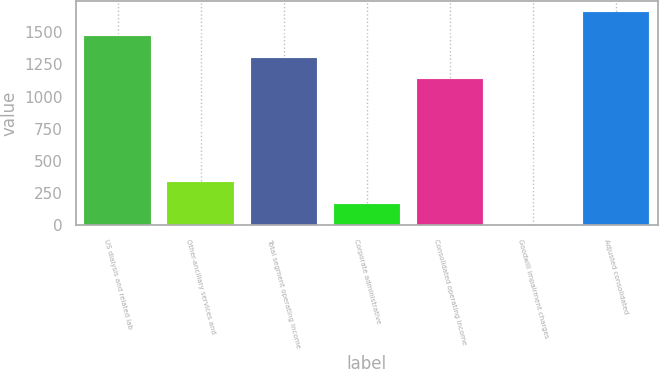Convert chart. <chart><loc_0><loc_0><loc_500><loc_500><bar_chart><fcel>US dialysis and related lab<fcel>Other-ancillary services and<fcel>Total segment operating income<fcel>Corporate administrative<fcel>Consolidated operating income<fcel>Goodwill impairment charges<fcel>Adjusted consolidated<nl><fcel>1467.8<fcel>334.8<fcel>1302.4<fcel>169.4<fcel>1137<fcel>4<fcel>1658<nl></chart> 